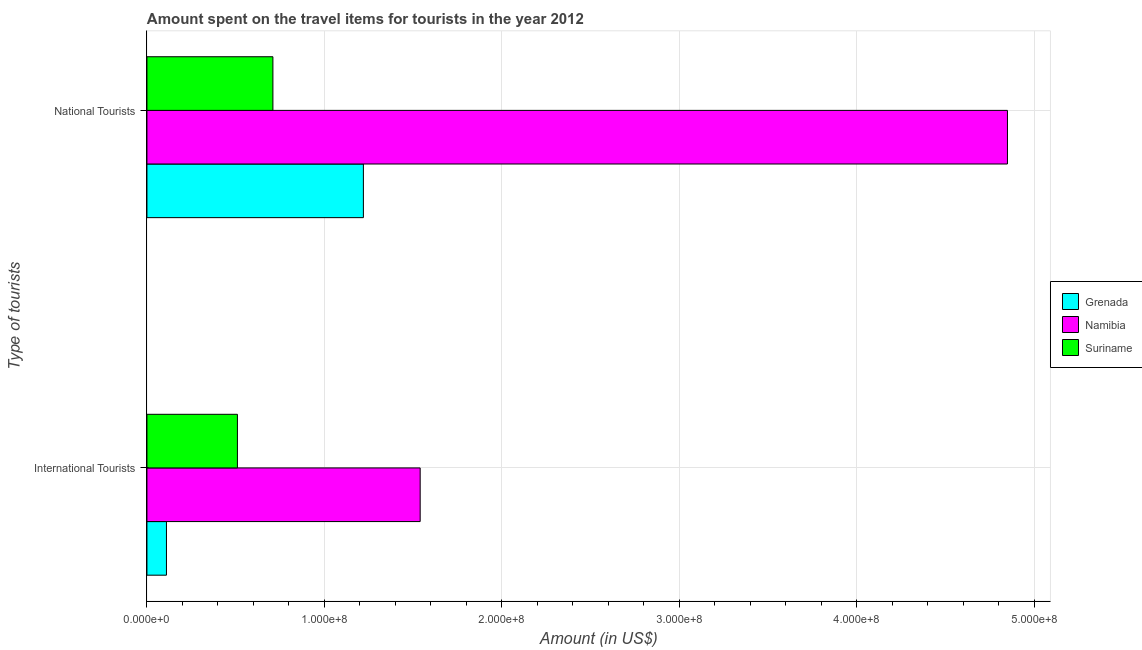How many different coloured bars are there?
Offer a very short reply. 3. How many groups of bars are there?
Provide a short and direct response. 2. Are the number of bars per tick equal to the number of legend labels?
Provide a succinct answer. Yes. How many bars are there on the 2nd tick from the top?
Make the answer very short. 3. What is the label of the 1st group of bars from the top?
Ensure brevity in your answer.  National Tourists. What is the amount spent on travel items of international tourists in Grenada?
Provide a succinct answer. 1.10e+07. Across all countries, what is the maximum amount spent on travel items of international tourists?
Provide a succinct answer. 1.54e+08. Across all countries, what is the minimum amount spent on travel items of international tourists?
Your answer should be very brief. 1.10e+07. In which country was the amount spent on travel items of international tourists maximum?
Offer a very short reply. Namibia. In which country was the amount spent on travel items of national tourists minimum?
Offer a very short reply. Suriname. What is the total amount spent on travel items of national tourists in the graph?
Your answer should be very brief. 6.78e+08. What is the difference between the amount spent on travel items of national tourists in Suriname and that in Namibia?
Make the answer very short. -4.14e+08. What is the difference between the amount spent on travel items of international tourists in Namibia and the amount spent on travel items of national tourists in Grenada?
Your answer should be compact. 3.20e+07. What is the average amount spent on travel items of national tourists per country?
Offer a terse response. 2.26e+08. What is the difference between the amount spent on travel items of international tourists and amount spent on travel items of national tourists in Suriname?
Provide a succinct answer. -2.00e+07. What is the ratio of the amount spent on travel items of international tourists in Suriname to that in Grenada?
Offer a very short reply. 4.64. What does the 2nd bar from the top in National Tourists represents?
Keep it short and to the point. Namibia. What does the 3rd bar from the bottom in International Tourists represents?
Offer a terse response. Suriname. Are all the bars in the graph horizontal?
Offer a very short reply. Yes. How many countries are there in the graph?
Your answer should be very brief. 3. What is the difference between two consecutive major ticks on the X-axis?
Provide a succinct answer. 1.00e+08. Are the values on the major ticks of X-axis written in scientific E-notation?
Offer a terse response. Yes. Does the graph contain grids?
Ensure brevity in your answer.  Yes. Where does the legend appear in the graph?
Your answer should be very brief. Center right. How are the legend labels stacked?
Keep it short and to the point. Vertical. What is the title of the graph?
Keep it short and to the point. Amount spent on the travel items for tourists in the year 2012. Does "Andorra" appear as one of the legend labels in the graph?
Offer a terse response. No. What is the label or title of the Y-axis?
Provide a succinct answer. Type of tourists. What is the Amount (in US$) in Grenada in International Tourists?
Provide a succinct answer. 1.10e+07. What is the Amount (in US$) of Namibia in International Tourists?
Your response must be concise. 1.54e+08. What is the Amount (in US$) in Suriname in International Tourists?
Provide a succinct answer. 5.10e+07. What is the Amount (in US$) in Grenada in National Tourists?
Your answer should be very brief. 1.22e+08. What is the Amount (in US$) of Namibia in National Tourists?
Make the answer very short. 4.85e+08. What is the Amount (in US$) in Suriname in National Tourists?
Keep it short and to the point. 7.10e+07. Across all Type of tourists, what is the maximum Amount (in US$) in Grenada?
Ensure brevity in your answer.  1.22e+08. Across all Type of tourists, what is the maximum Amount (in US$) of Namibia?
Your answer should be very brief. 4.85e+08. Across all Type of tourists, what is the maximum Amount (in US$) in Suriname?
Provide a short and direct response. 7.10e+07. Across all Type of tourists, what is the minimum Amount (in US$) in Grenada?
Provide a succinct answer. 1.10e+07. Across all Type of tourists, what is the minimum Amount (in US$) of Namibia?
Provide a short and direct response. 1.54e+08. Across all Type of tourists, what is the minimum Amount (in US$) of Suriname?
Give a very brief answer. 5.10e+07. What is the total Amount (in US$) of Grenada in the graph?
Your response must be concise. 1.33e+08. What is the total Amount (in US$) of Namibia in the graph?
Ensure brevity in your answer.  6.39e+08. What is the total Amount (in US$) in Suriname in the graph?
Offer a terse response. 1.22e+08. What is the difference between the Amount (in US$) of Grenada in International Tourists and that in National Tourists?
Your answer should be very brief. -1.11e+08. What is the difference between the Amount (in US$) of Namibia in International Tourists and that in National Tourists?
Keep it short and to the point. -3.31e+08. What is the difference between the Amount (in US$) of Suriname in International Tourists and that in National Tourists?
Your answer should be compact. -2.00e+07. What is the difference between the Amount (in US$) of Grenada in International Tourists and the Amount (in US$) of Namibia in National Tourists?
Provide a short and direct response. -4.74e+08. What is the difference between the Amount (in US$) of Grenada in International Tourists and the Amount (in US$) of Suriname in National Tourists?
Provide a short and direct response. -6.00e+07. What is the difference between the Amount (in US$) of Namibia in International Tourists and the Amount (in US$) of Suriname in National Tourists?
Provide a succinct answer. 8.30e+07. What is the average Amount (in US$) in Grenada per Type of tourists?
Ensure brevity in your answer.  6.65e+07. What is the average Amount (in US$) in Namibia per Type of tourists?
Make the answer very short. 3.20e+08. What is the average Amount (in US$) of Suriname per Type of tourists?
Your response must be concise. 6.10e+07. What is the difference between the Amount (in US$) in Grenada and Amount (in US$) in Namibia in International Tourists?
Offer a terse response. -1.43e+08. What is the difference between the Amount (in US$) of Grenada and Amount (in US$) of Suriname in International Tourists?
Your response must be concise. -4.00e+07. What is the difference between the Amount (in US$) of Namibia and Amount (in US$) of Suriname in International Tourists?
Your answer should be compact. 1.03e+08. What is the difference between the Amount (in US$) in Grenada and Amount (in US$) in Namibia in National Tourists?
Give a very brief answer. -3.63e+08. What is the difference between the Amount (in US$) of Grenada and Amount (in US$) of Suriname in National Tourists?
Give a very brief answer. 5.10e+07. What is the difference between the Amount (in US$) of Namibia and Amount (in US$) of Suriname in National Tourists?
Your response must be concise. 4.14e+08. What is the ratio of the Amount (in US$) of Grenada in International Tourists to that in National Tourists?
Give a very brief answer. 0.09. What is the ratio of the Amount (in US$) in Namibia in International Tourists to that in National Tourists?
Provide a succinct answer. 0.32. What is the ratio of the Amount (in US$) of Suriname in International Tourists to that in National Tourists?
Your response must be concise. 0.72. What is the difference between the highest and the second highest Amount (in US$) in Grenada?
Your response must be concise. 1.11e+08. What is the difference between the highest and the second highest Amount (in US$) in Namibia?
Provide a short and direct response. 3.31e+08. What is the difference between the highest and the second highest Amount (in US$) in Suriname?
Your answer should be compact. 2.00e+07. What is the difference between the highest and the lowest Amount (in US$) in Grenada?
Offer a terse response. 1.11e+08. What is the difference between the highest and the lowest Amount (in US$) of Namibia?
Offer a terse response. 3.31e+08. What is the difference between the highest and the lowest Amount (in US$) of Suriname?
Give a very brief answer. 2.00e+07. 